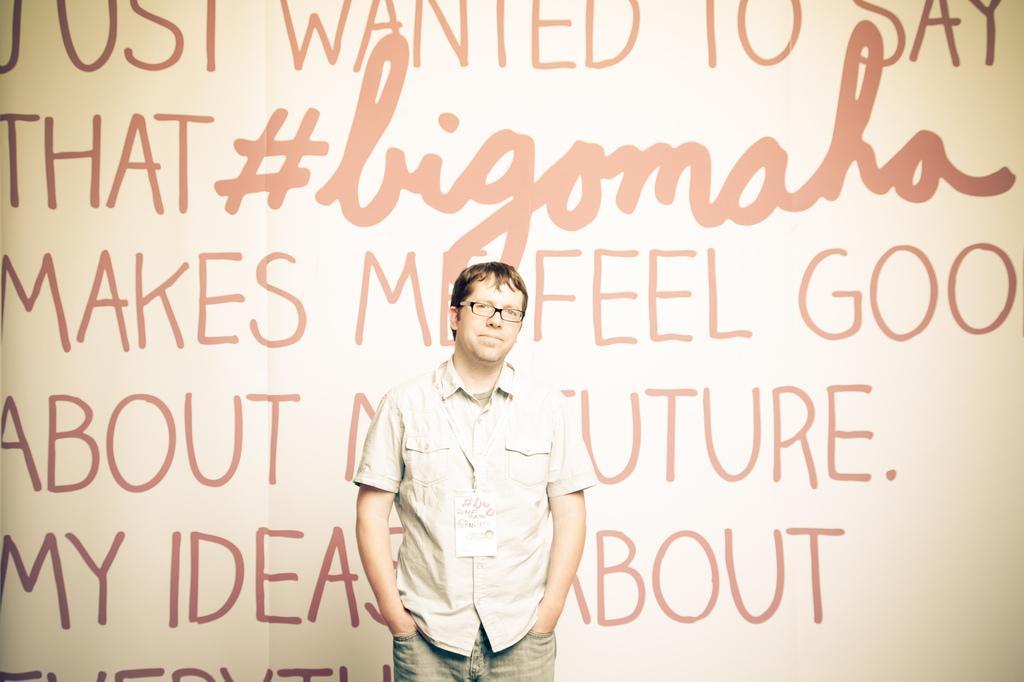Please provide a concise description of this image. In this picture I can see a man standing, He wore a ID card and spectacles and I can see text on the background. 